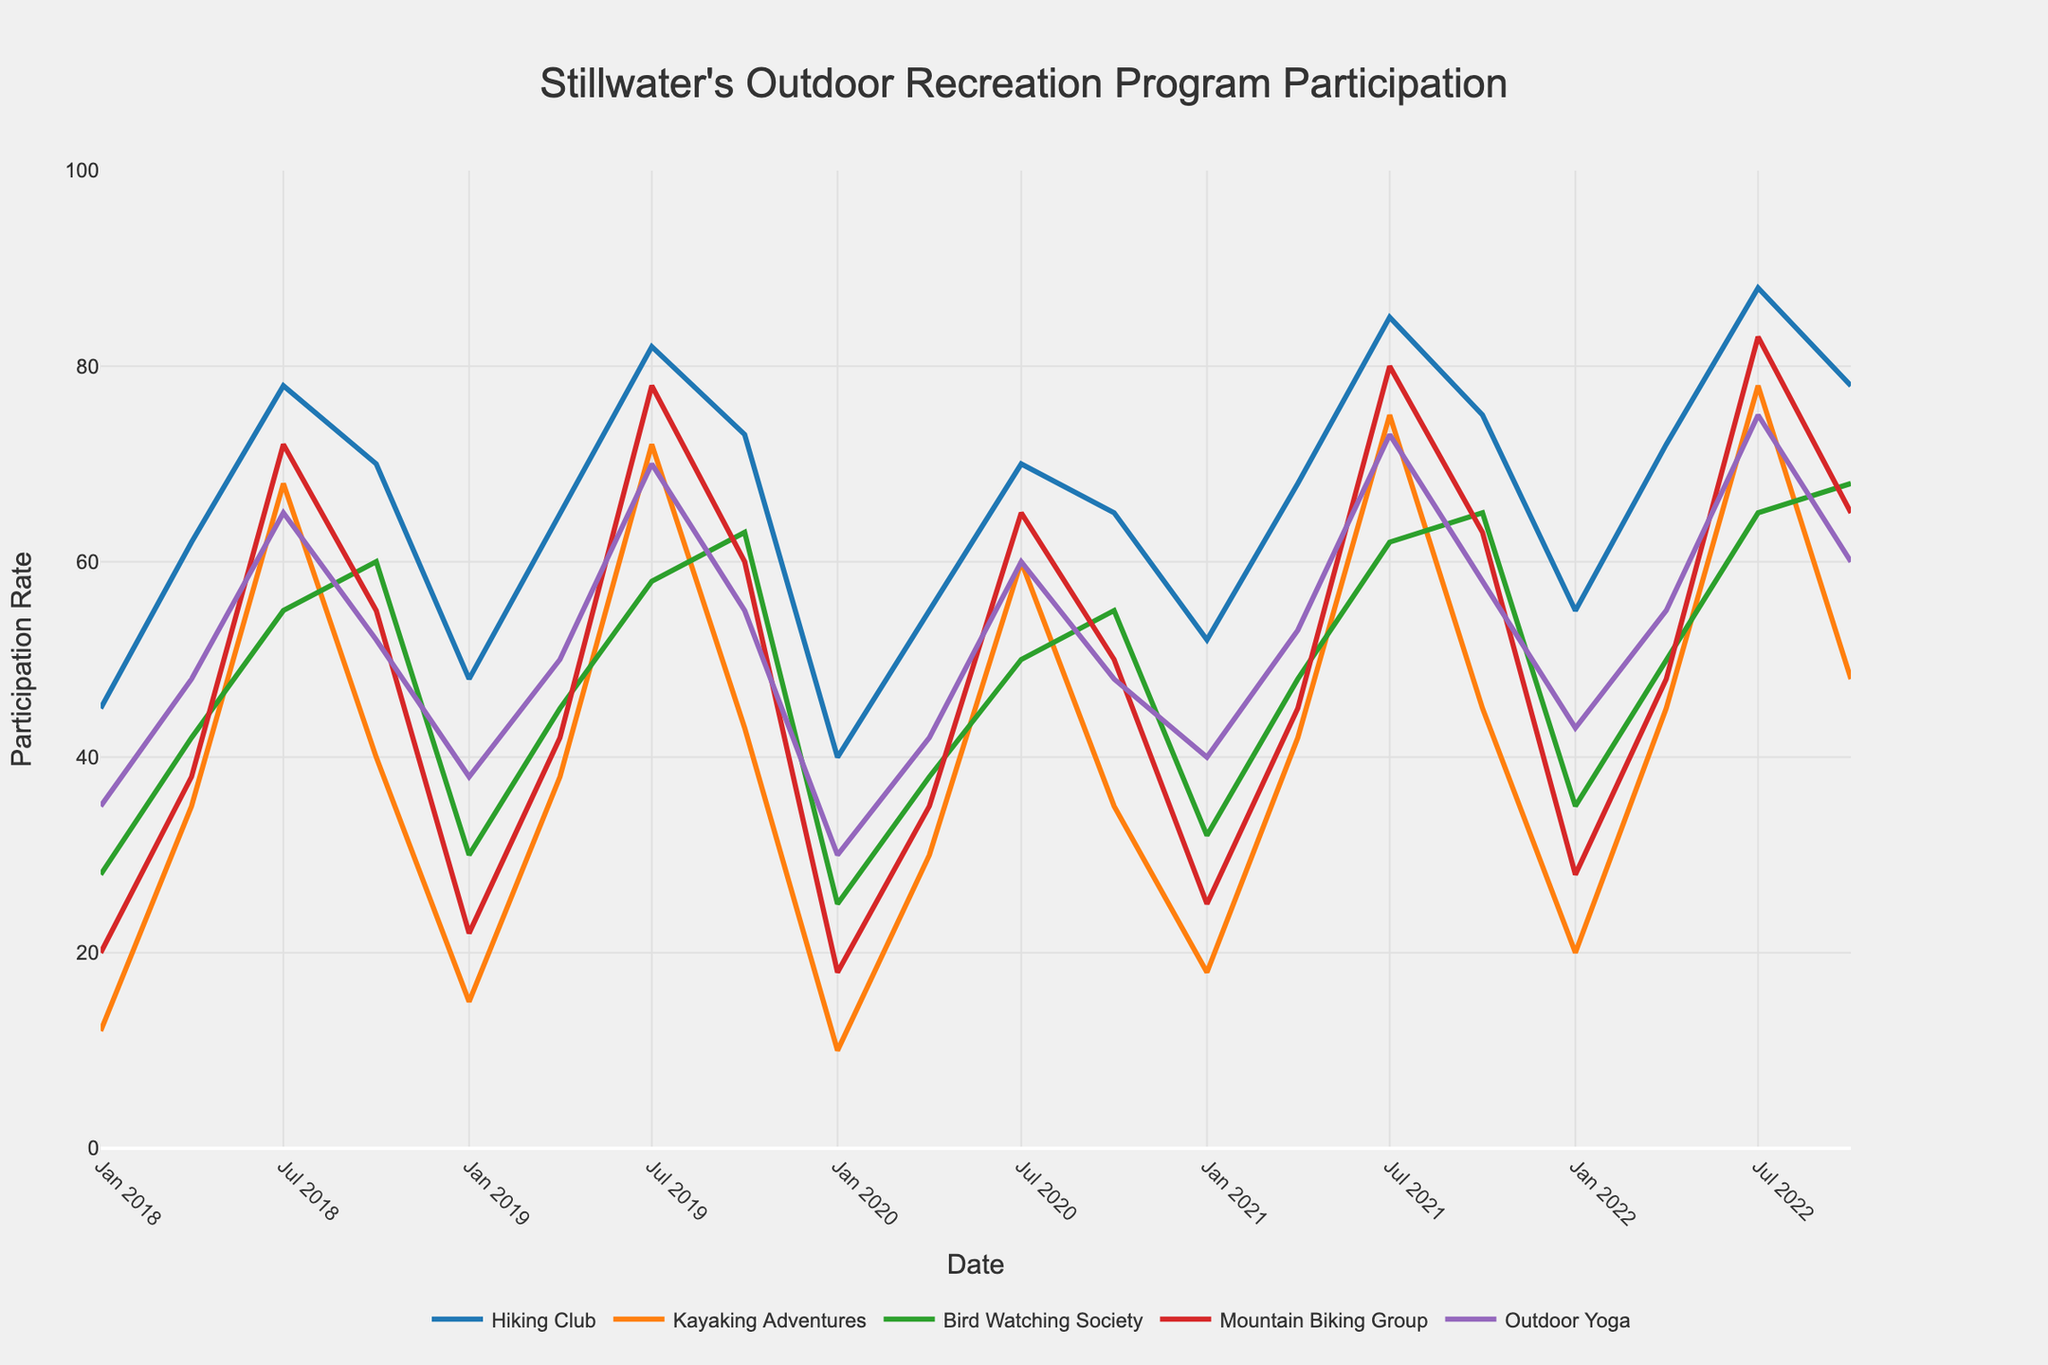how does the participation in the Hiking Club change from Jan 2018 to Oct 2022? To find the change, look at the participation in the Hiking Club in Jan 2018 (45 participants) and Oct 2022 (78 participants). Calculate the difference: 78 - 45.
Answer: 33 In which activity did the participation rate show the most increase from Jul 2018 to Jul 2022? Compare the participation rates for each activity from Jul 2018 to Jul 2022. For Hiking Club: 88-78=10; Kayaking Adventures: 78-68=10; Bird Watching Society: 65-55=10; Mountain Biking Group: 83-72=11; Outdoor Yoga: 75-65=10. Mountain Biking Group shows the highest increase of 11.
Answer: Mountain Biking Group Which activity had the lowest participation rate in Jan 2020? Refer to Jan 2020 and find the activity with the lowest participation rate. Hiking Club: 40, Kayaking Adventures: 10, Bird Watching Society: 25, Mountain Biking Group: 18, Outdoor Yoga: 30. Kayaking Adventures has the lowest rate of 10.
Answer: Kayaking Adventures What is the average participation in Outdoor Yoga during the month of Jul across all years? Calculate the average by adding participation rates in Jul for Outdoor Yoga across all years and divide by the number of years. (65+70+60+73+75)/5 = 68.6.
Answer: 68.6 How does the participation rate in Bird Watching Society in Oct 2018 compare to Jan 2021? Look for the participation rates in Bird Watching Society in Oct 2018 (60 participants) and Jan 2021 (32 participants). Compare 60 with 32 to see that Oct 2018 had a higher rate.
Answer: Oct 2018 had a higher rate What is the overall trend in participation rates for Kayaking Adventures from Jan 2018 to Oct 2022? Observe the plotted points for Kayaking Adventures from Jan 2018 (12 participants) to Oct 2022 (48 participants). The graph shows a general upward trend over time.
Answer: Upward trend Which activity saw a peak in participation in Jul 2021? For Jul 2021, check the participation rates: Hiking Club: 85, Kayaking Adventures: 75, Bird Watching Society: 62, Mountain Biking Group: 80, Outdoor Yoga: 73. Hiking Club had the peak with 85 participants.
Answer: Hiking Club What is the difference in participation rates between Mountain Biking Group and Bird Watching Society in Apr 2022? For Apr 2022, find the rates: Mountain Biking Group: 48, Bird Watching Society: 50. Calculate the difference: 50 - 48.
Answer: 2 